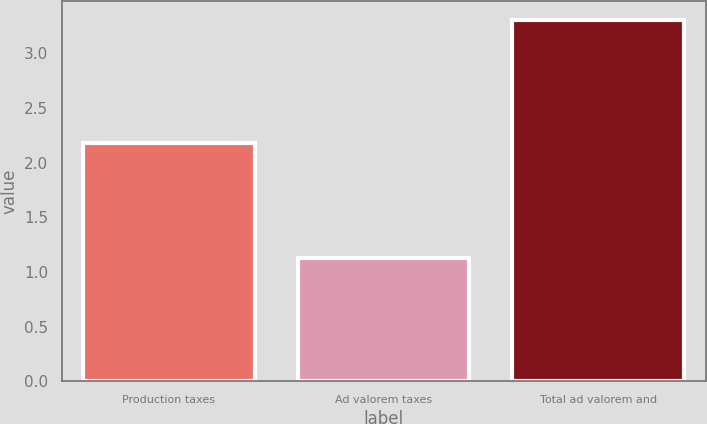Convert chart to OTSL. <chart><loc_0><loc_0><loc_500><loc_500><bar_chart><fcel>Production taxes<fcel>Ad valorem taxes<fcel>Total ad valorem and<nl><fcel>2.18<fcel>1.13<fcel>3.31<nl></chart> 